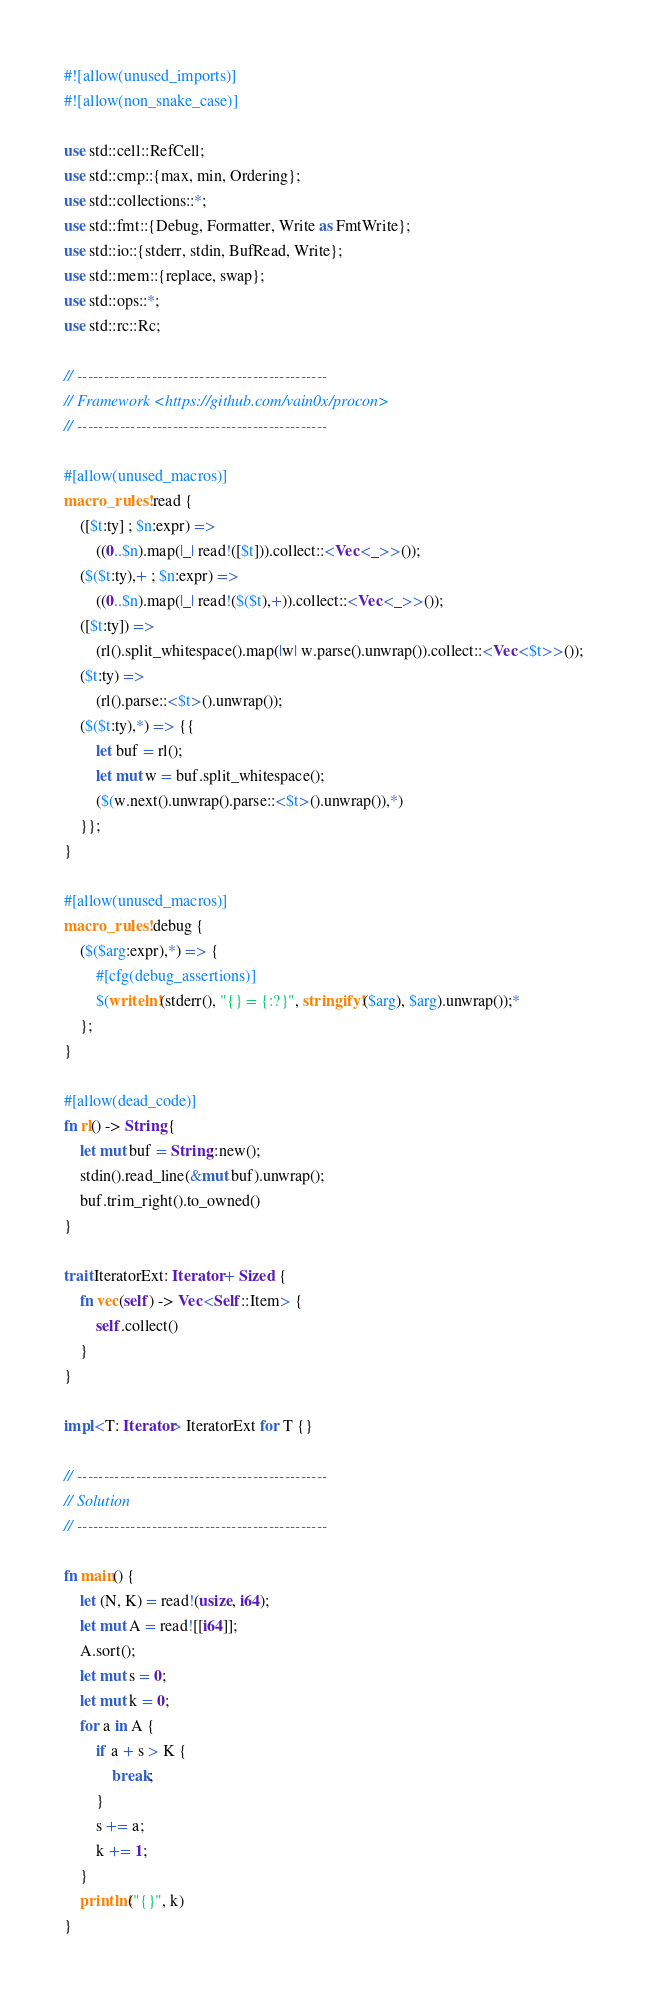<code> <loc_0><loc_0><loc_500><loc_500><_Rust_>#![allow(unused_imports)]
#![allow(non_snake_case)]

use std::cell::RefCell;
use std::cmp::{max, min, Ordering};
use std::collections::*;
use std::fmt::{Debug, Formatter, Write as FmtWrite};
use std::io::{stderr, stdin, BufRead, Write};
use std::mem::{replace, swap};
use std::ops::*;
use std::rc::Rc;

// -----------------------------------------------
// Framework <https://github.com/vain0x/procon>
// -----------------------------------------------

#[allow(unused_macros)]
macro_rules! read {
    ([$t:ty] ; $n:expr) =>
        ((0..$n).map(|_| read!([$t])).collect::<Vec<_>>());
    ($($t:ty),+ ; $n:expr) =>
        ((0..$n).map(|_| read!($($t),+)).collect::<Vec<_>>());
    ([$t:ty]) =>
        (rl().split_whitespace().map(|w| w.parse().unwrap()).collect::<Vec<$t>>());
    ($t:ty) =>
        (rl().parse::<$t>().unwrap());
    ($($t:ty),*) => {{
        let buf = rl();
        let mut w = buf.split_whitespace();
        ($(w.next().unwrap().parse::<$t>().unwrap()),*)
    }};
}

#[allow(unused_macros)]
macro_rules! debug {
    ($($arg:expr),*) => {
        #[cfg(debug_assertions)]
        $(writeln!(stderr(), "{} = {:?}", stringify!($arg), $arg).unwrap());*
    };
}

#[allow(dead_code)]
fn rl() -> String {
    let mut buf = String::new();
    stdin().read_line(&mut buf).unwrap();
    buf.trim_right().to_owned()
}

trait IteratorExt: Iterator + Sized {
    fn vec(self) -> Vec<Self::Item> {
        self.collect()
    }
}

impl<T: Iterator> IteratorExt for T {}

// -----------------------------------------------
// Solution
// -----------------------------------------------

fn main() {
    let (N, K) = read!(usize, i64);
    let mut A = read![[i64]];
    A.sort();
    let mut s = 0;
    let mut k = 0;
    for a in A {
        if a + s > K {
            break;
        }
        s += a;
        k += 1;
    }
    println!("{}", k)
}
</code> 